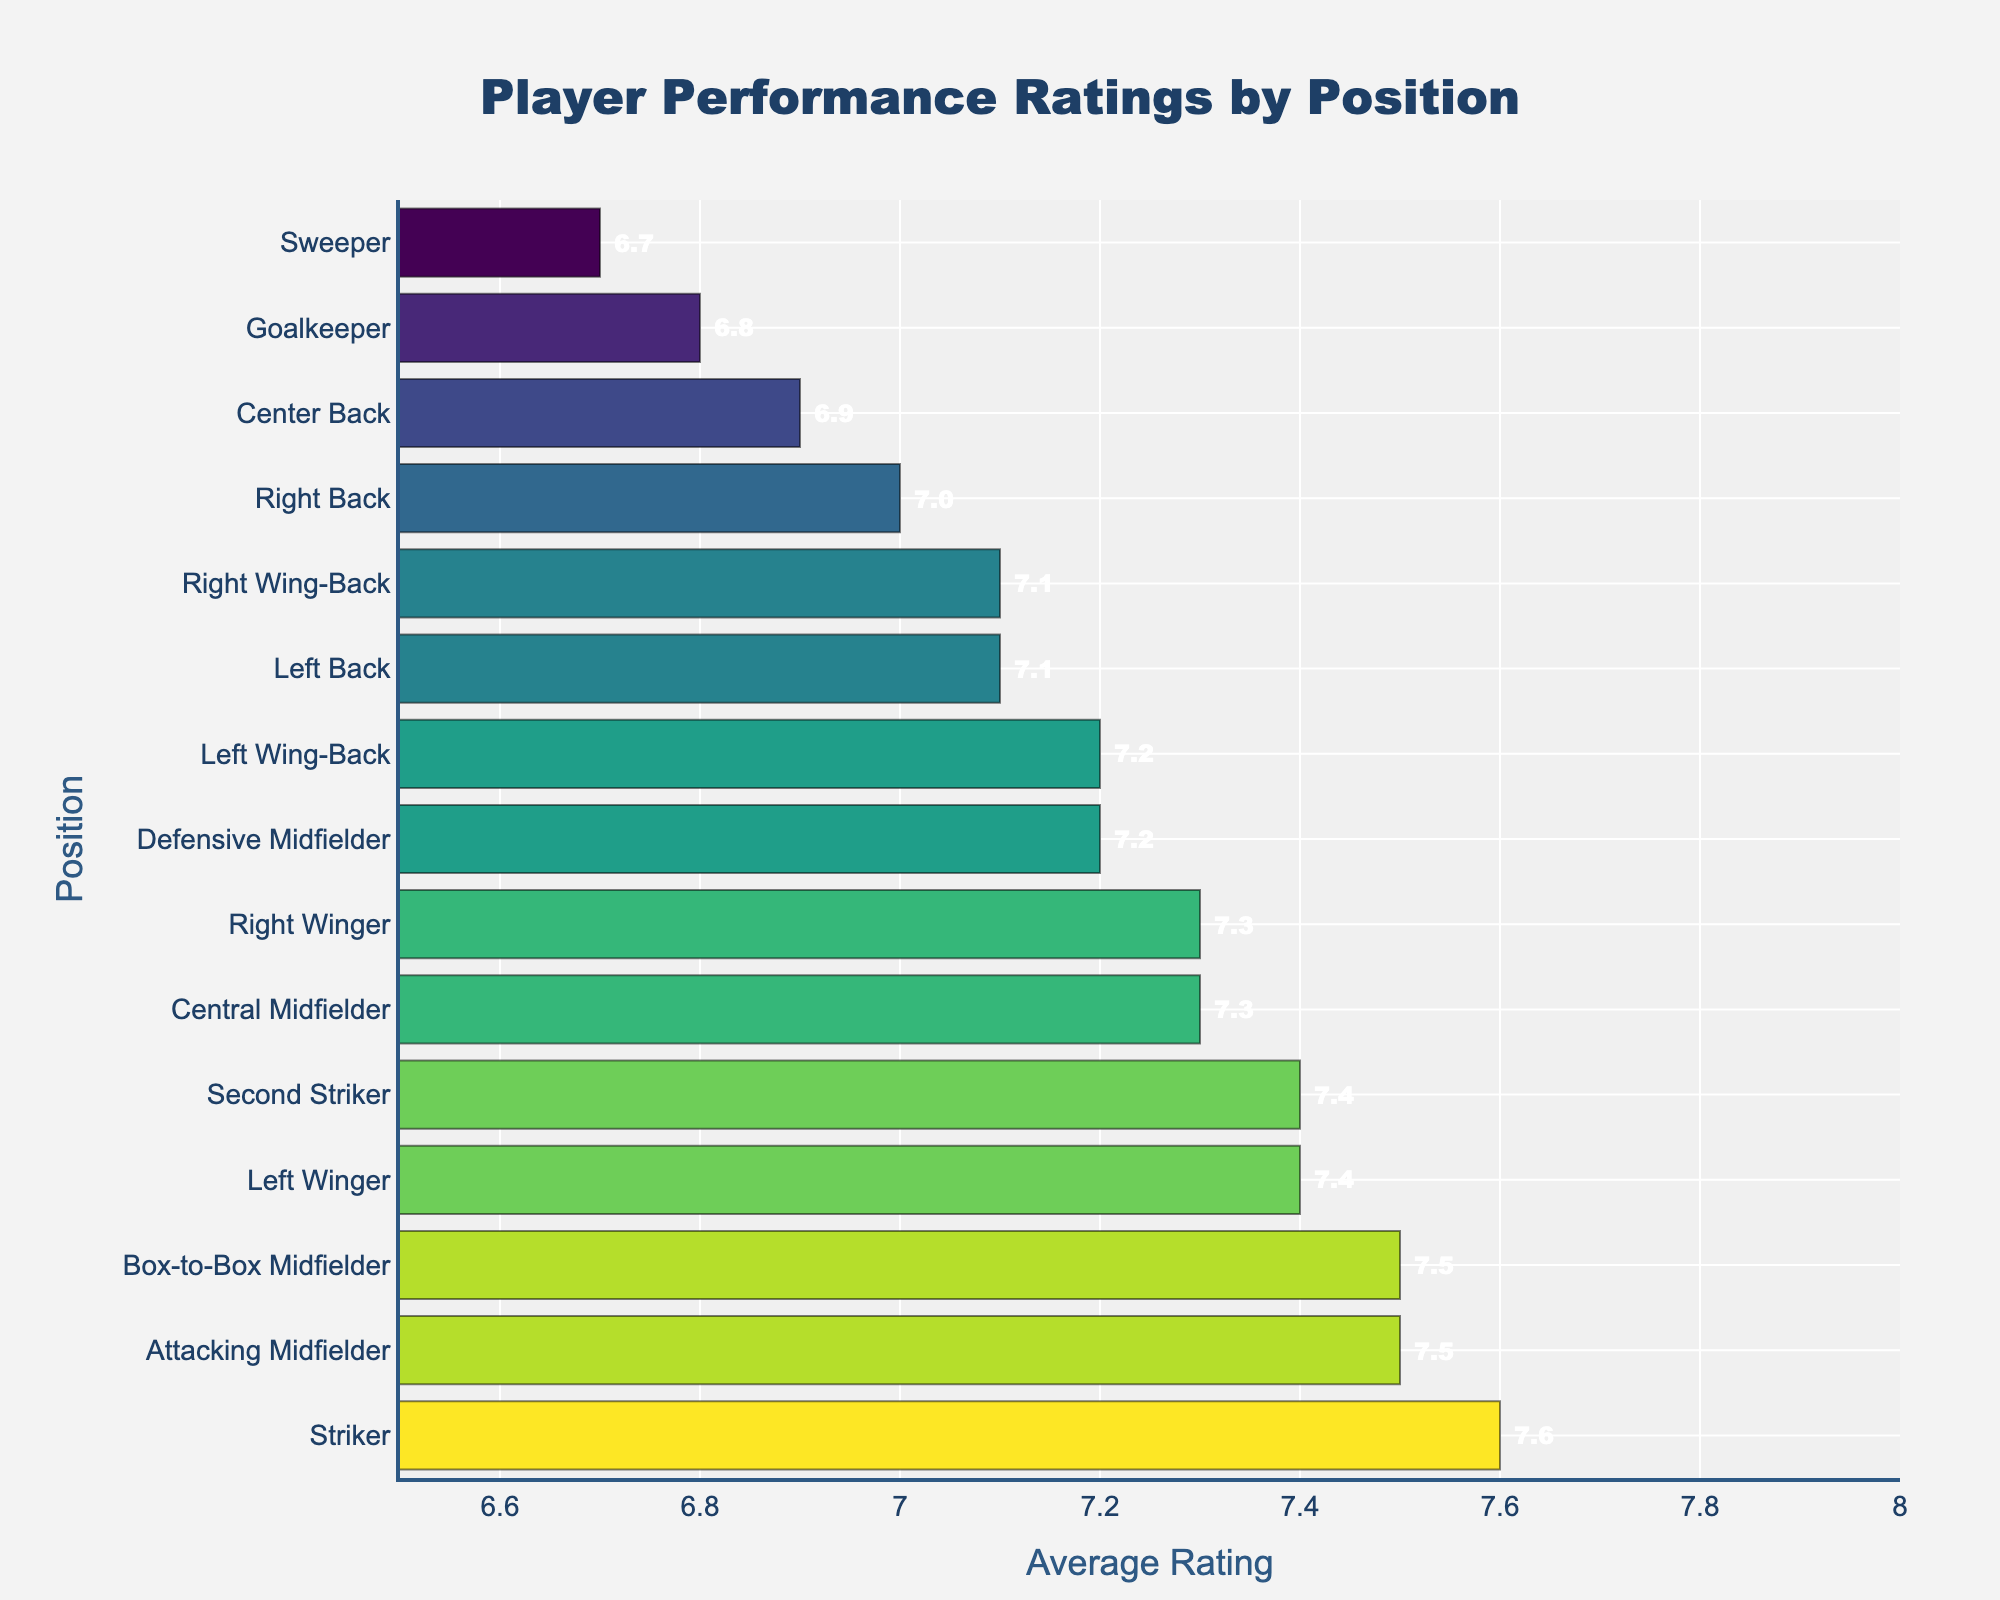Which position has the highest average rating? To determine the highest average rating, look for the bar that extends the farthest to the right. The bar corresponding to the "Striker" position is the longest, indicating the highest rating.
Answer: Striker Which position has a lower average rating, Goalkeeper or Sweeper? To compare these two positions, find their bars on the chart. The Sweeper has a lower numeric value for the average rating compared to the Goalkeeper.
Answer: Sweeper What is the difference in average rating between the Central Midfielder and the Box-to-Box Midfielder? Identify the bars for these two positions and note their respective values. Central Midfielder has a rating of 7.3 and Box-to-Box Midfielder has 7.5. Subtract the smaller from the larger to get the difference, 7.5 - 7.3 = 0.2.
Answer: 0.2 Which types of midfielders have an average rating greater than 7.0? Check the bars for all midfield positions and note their values. Central Midfielder, Attacking Midfielder, Defensive Midfielder, Box-to-Box Midfielder, and Right Wing-Back all have ratings above 7.0.
Answer: Central Midfielder, Attacking Midfielder, Defensive Midfielder, Box-to-Box Midfielder, Right Wing-Back Which position has a closer average rating to the Right Winger, Central Midfielder or Left Wing-Back? Compare the bar lengths for positions Central Midfielder, Left Wing-Back, and Right Winger. The Central Midfielder has a rating of 7.3, and Left Wing-Back has 7.2, compared to Right Winger's 7.3. Left Wing-Back (7.2) is closer to 7.3.
Answer: Central Midfielder What is the combined average rating of Goalkeeper, Left Back, and Right Back? Identify the bars for these positions and note their ratings: Goalkeeper (6.8), Left Back (7.1), and Right Back (7.0). Sum these ratings: 6.8 + 7.1 + 7.0 = 20.9.
Answer: 20.9 Is the average rating of Left Winger closer to the Striker or the Second Striker? Compare the ratings visually: Striker (7.6), Second Striker (7.4), and Left Winger (7.4). The Left Winger’s rating (7.4) is equal to that of the Second Striker and closer to it than to Striker (7.6).
Answer: Second Striker Does the average rating of the Right Wing-Back exceed that of the Sweeper position by more than 0.3? Compare the ratings: Right Wing-Back (7.1) and Sweeper (6.7). The difference is 7.1 - 6.7 = 0.4, which exceeds 0.3.
Answer: Yes Which position has the second-highest average rating? Identify the position with the second-longest bar after the Striker. The second-longest bar corresponds to the "Attacking Midfielder" position with a rating of 7.5.
Answer: Attacking Midfielder How many positions have an average rating less than 7.0? Count the positions where the bars extend less than the 7.0 mark. Positions are Goalkeeper, Center Back, Sweeper, and Right Back. There are four in total.
Answer: 4 